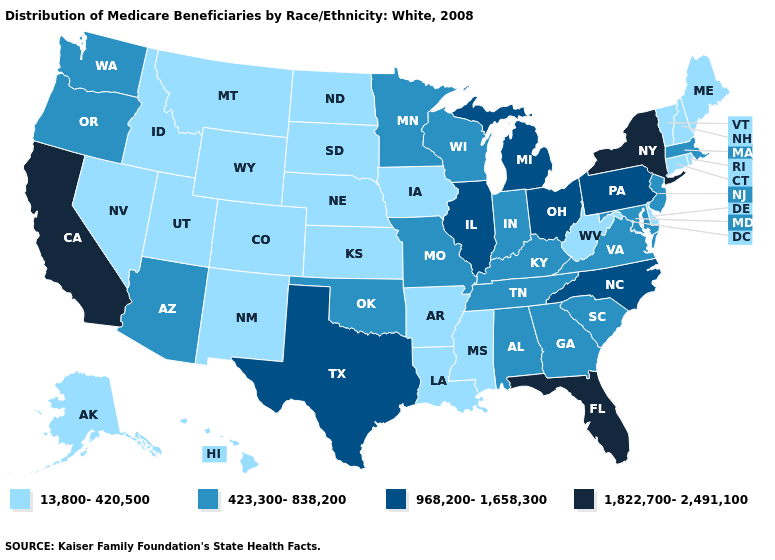Does Mississippi have the highest value in the USA?
Short answer required. No. Does Colorado have the lowest value in the West?
Keep it brief. Yes. Does Missouri have the same value as Connecticut?
Give a very brief answer. No. What is the highest value in the South ?
Write a very short answer. 1,822,700-2,491,100. Among the states that border Rhode Island , does Massachusetts have the lowest value?
Quick response, please. No. Name the states that have a value in the range 1,822,700-2,491,100?
Short answer required. California, Florida, New York. What is the highest value in states that border Connecticut?
Give a very brief answer. 1,822,700-2,491,100. What is the highest value in the South ?
Keep it brief. 1,822,700-2,491,100. Among the states that border New Hampshire , does Vermont have the highest value?
Give a very brief answer. No. Name the states that have a value in the range 423,300-838,200?
Write a very short answer. Alabama, Arizona, Georgia, Indiana, Kentucky, Maryland, Massachusetts, Minnesota, Missouri, New Jersey, Oklahoma, Oregon, South Carolina, Tennessee, Virginia, Washington, Wisconsin. Among the states that border Arizona , which have the highest value?
Be succinct. California. Which states have the lowest value in the USA?
Give a very brief answer. Alaska, Arkansas, Colorado, Connecticut, Delaware, Hawaii, Idaho, Iowa, Kansas, Louisiana, Maine, Mississippi, Montana, Nebraska, Nevada, New Hampshire, New Mexico, North Dakota, Rhode Island, South Dakota, Utah, Vermont, West Virginia, Wyoming. Name the states that have a value in the range 423,300-838,200?
Quick response, please. Alabama, Arizona, Georgia, Indiana, Kentucky, Maryland, Massachusetts, Minnesota, Missouri, New Jersey, Oklahoma, Oregon, South Carolina, Tennessee, Virginia, Washington, Wisconsin. What is the value of Wyoming?
Keep it brief. 13,800-420,500. 